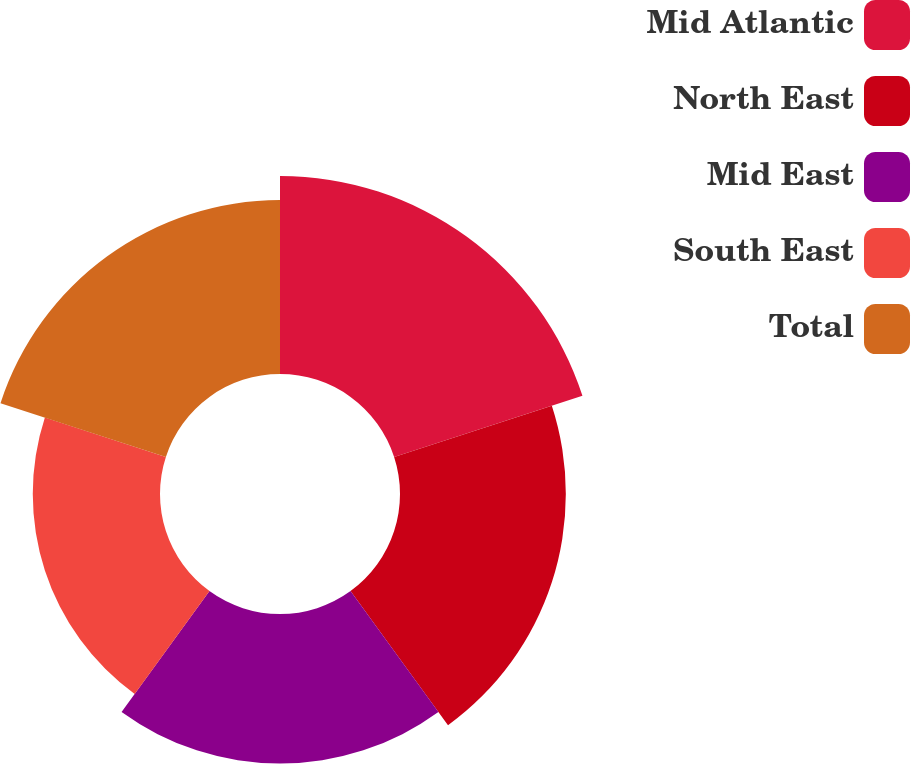Convert chart. <chart><loc_0><loc_0><loc_500><loc_500><pie_chart><fcel>Mid Atlantic<fcel>North East<fcel>Mid East<fcel>South East<fcel>Total<nl><fcel>24.31%<fcel>20.36%<fcel>18.36%<fcel>15.62%<fcel>21.35%<nl></chart> 